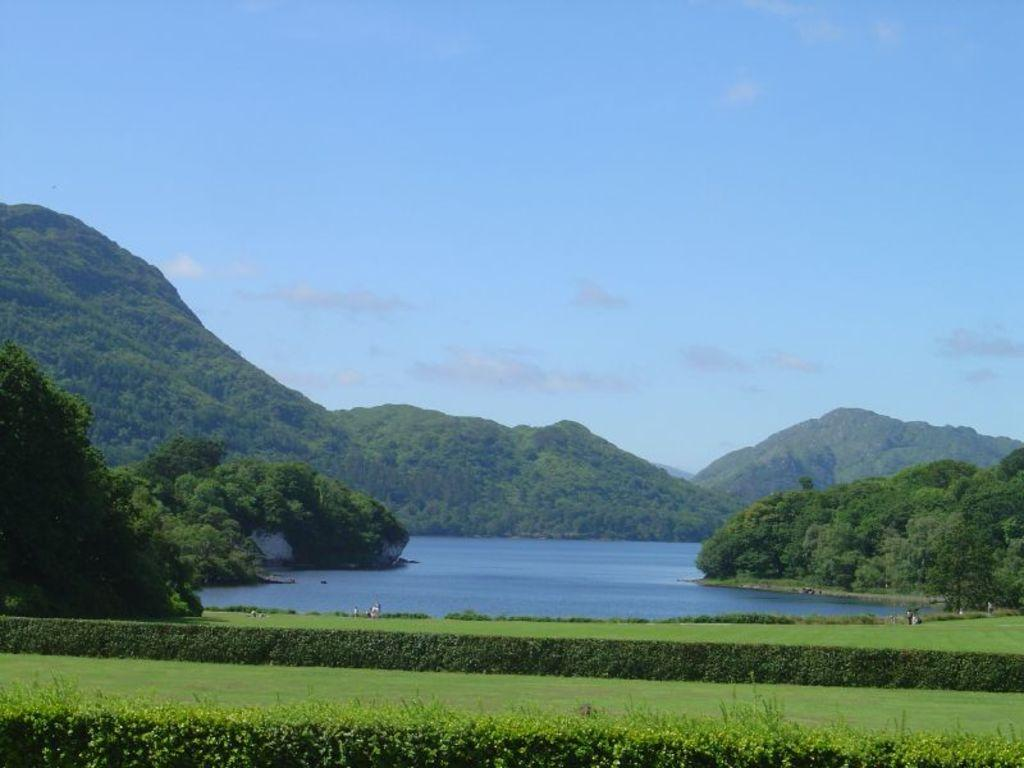What type of vegetation can be seen in the image? There is a group of trees in the image. What geographical features are present in the image? There are mountains and a lake in the image. What can be seen in the background of the image? The sky is visible in the background of the image. How many toes are visible in the image? There are no toes present in the image. What type of whip can be seen in the image? There is no whip present in the image. 